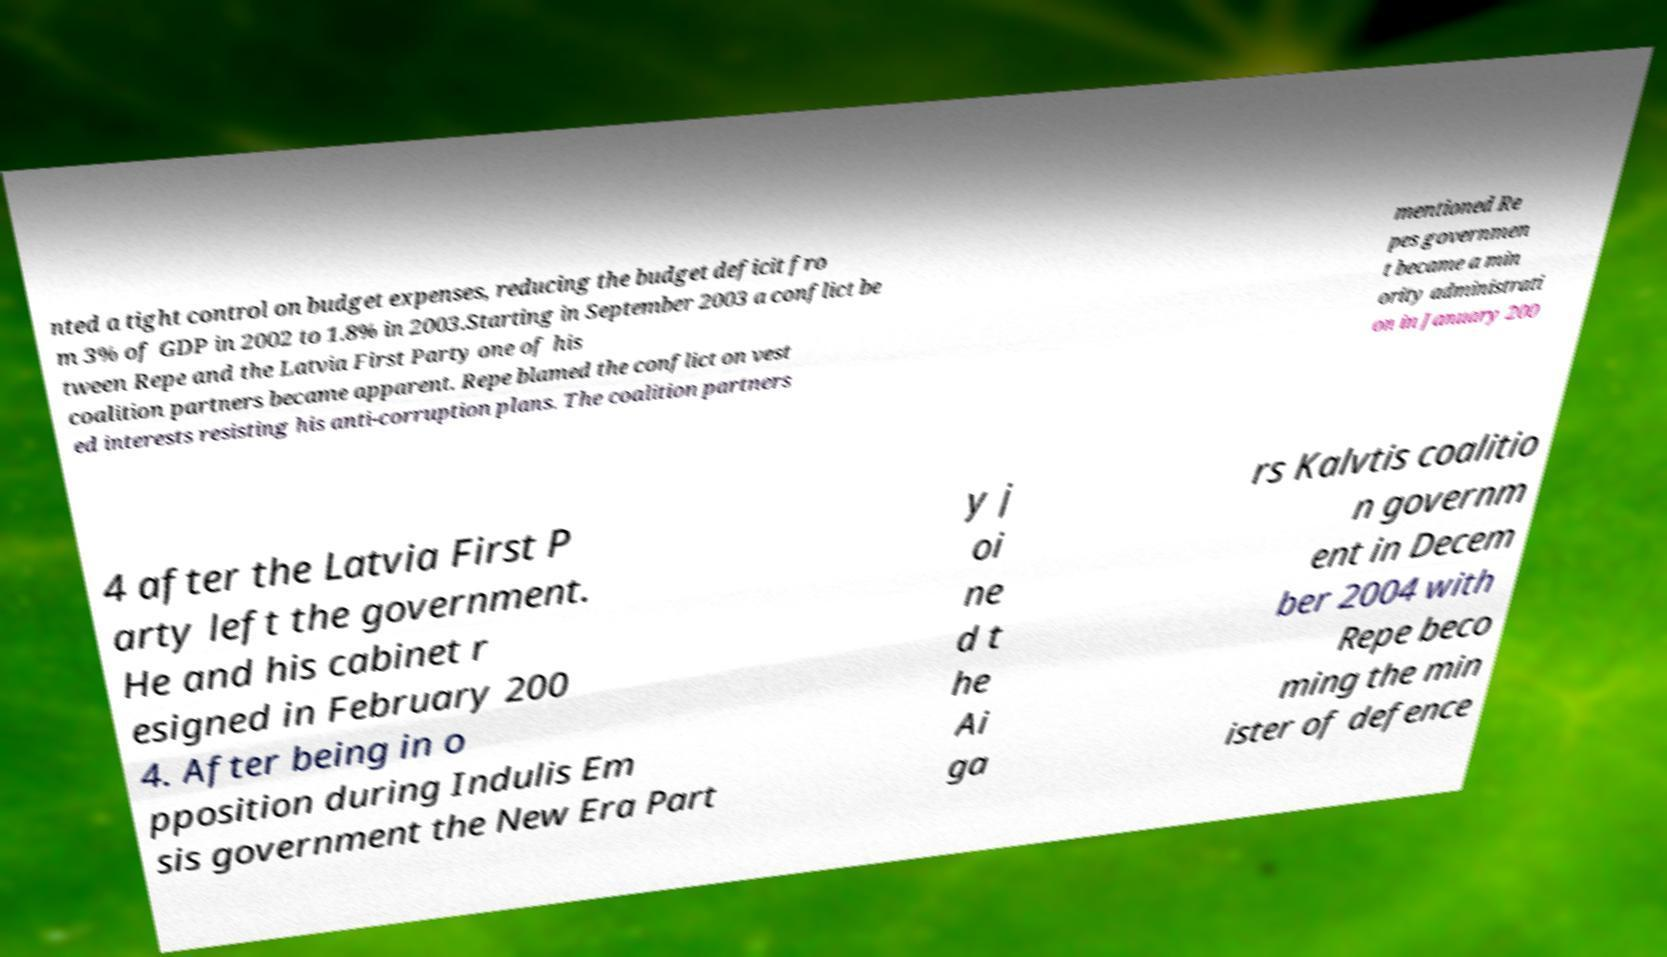For documentation purposes, I need the text within this image transcribed. Could you provide that? nted a tight control on budget expenses, reducing the budget deficit fro m 3% of GDP in 2002 to 1.8% in 2003.Starting in September 2003 a conflict be tween Repe and the Latvia First Party one of his coalition partners became apparent. Repe blamed the conflict on vest ed interests resisting his anti-corruption plans. The coalition partners mentioned Re pes governmen t became a min ority administrati on in January 200 4 after the Latvia First P arty left the government. He and his cabinet r esigned in February 200 4. After being in o pposition during Indulis Em sis government the New Era Part y j oi ne d t he Ai ga rs Kalvtis coalitio n governm ent in Decem ber 2004 with Repe beco ming the min ister of defence 